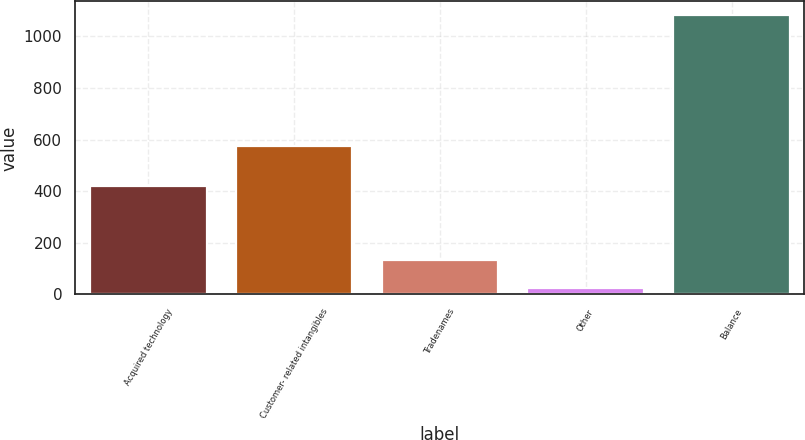Convert chart. <chart><loc_0><loc_0><loc_500><loc_500><bar_chart><fcel>Acquired technology<fcel>Customer- related intangibles<fcel>Tradenames<fcel>Other<fcel>Balance<nl><fcel>421<fcel>574<fcel>131.6<fcel>26<fcel>1082<nl></chart> 